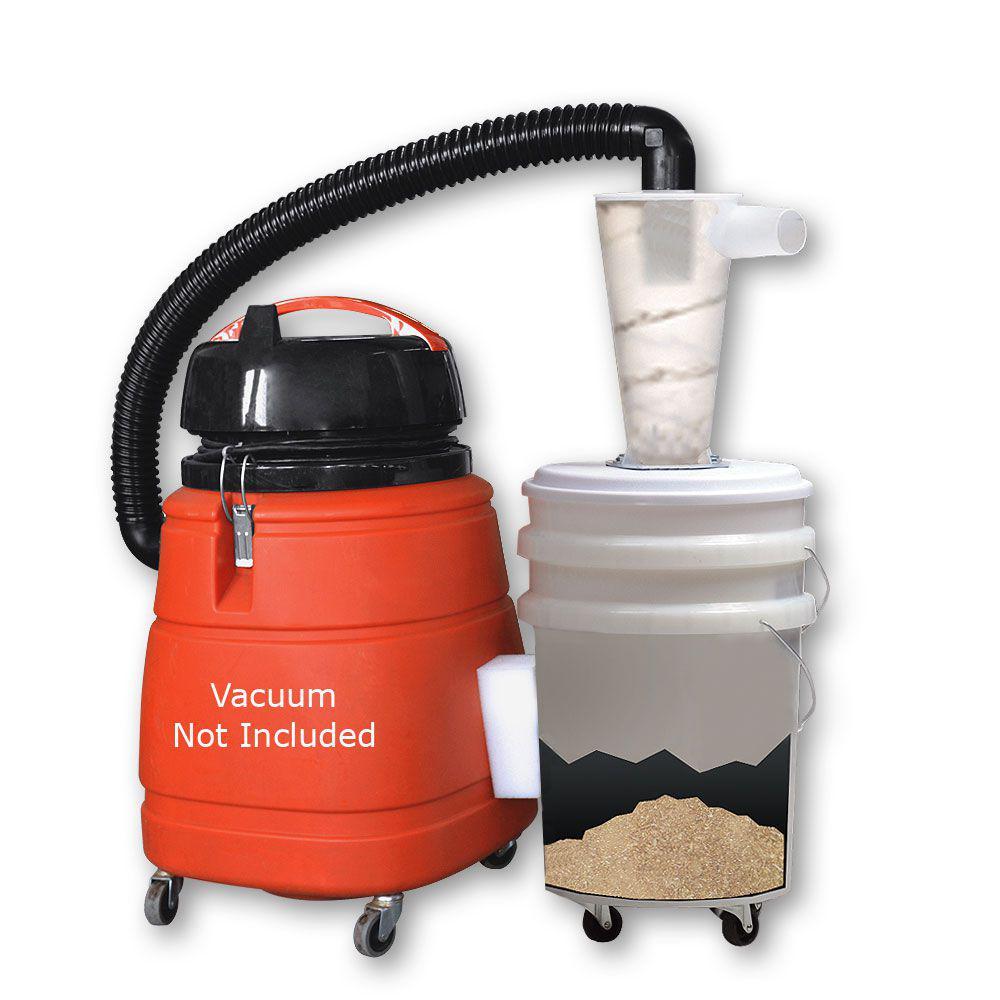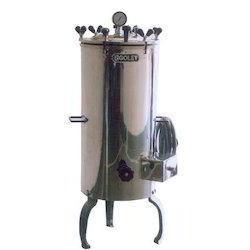The first image is the image on the left, the second image is the image on the right. Given the left and right images, does the statement "There is a shiny silver machine in one image, and something red/orange in the other." hold true? Answer yes or no. Yes. The first image is the image on the left, the second image is the image on the right. For the images shown, is this caption "There are more containers in the image on the right." true? Answer yes or no. No. 